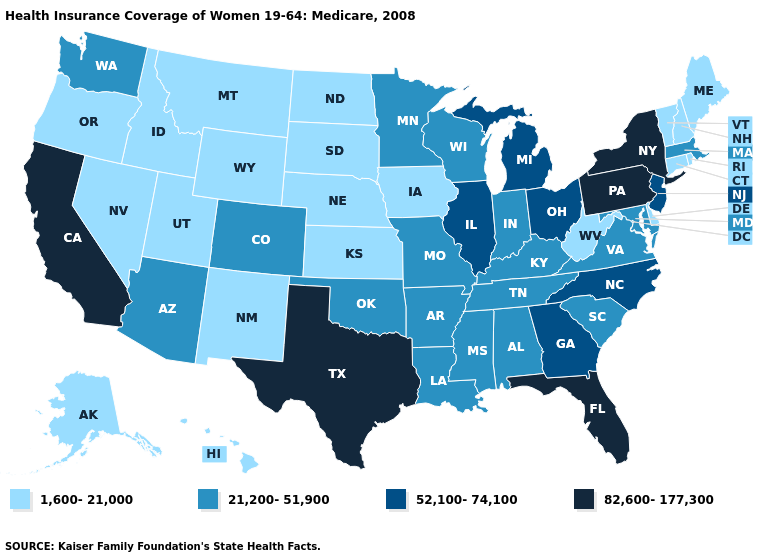Among the states that border Wyoming , does Utah have the highest value?
Answer briefly. No. Name the states that have a value in the range 82,600-177,300?
Answer briefly. California, Florida, New York, Pennsylvania, Texas. Does the first symbol in the legend represent the smallest category?
Keep it brief. Yes. Which states have the lowest value in the Northeast?
Quick response, please. Connecticut, Maine, New Hampshire, Rhode Island, Vermont. Name the states that have a value in the range 82,600-177,300?
Keep it brief. California, Florida, New York, Pennsylvania, Texas. Does the first symbol in the legend represent the smallest category?
Be succinct. Yes. Among the states that border Illinois , does Missouri have the lowest value?
Keep it brief. No. Does the first symbol in the legend represent the smallest category?
Keep it brief. Yes. Does New Mexico have a lower value than Tennessee?
Short answer required. Yes. Name the states that have a value in the range 52,100-74,100?
Answer briefly. Georgia, Illinois, Michigan, New Jersey, North Carolina, Ohio. Does the first symbol in the legend represent the smallest category?
Concise answer only. Yes. Which states hav the highest value in the South?
Quick response, please. Florida, Texas. Does Arkansas have the lowest value in the USA?
Quick response, please. No. Name the states that have a value in the range 82,600-177,300?
Concise answer only. California, Florida, New York, Pennsylvania, Texas. Does Kansas have the lowest value in the MidWest?
Give a very brief answer. Yes. 